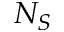<formula> <loc_0><loc_0><loc_500><loc_500>N _ { S }</formula> 